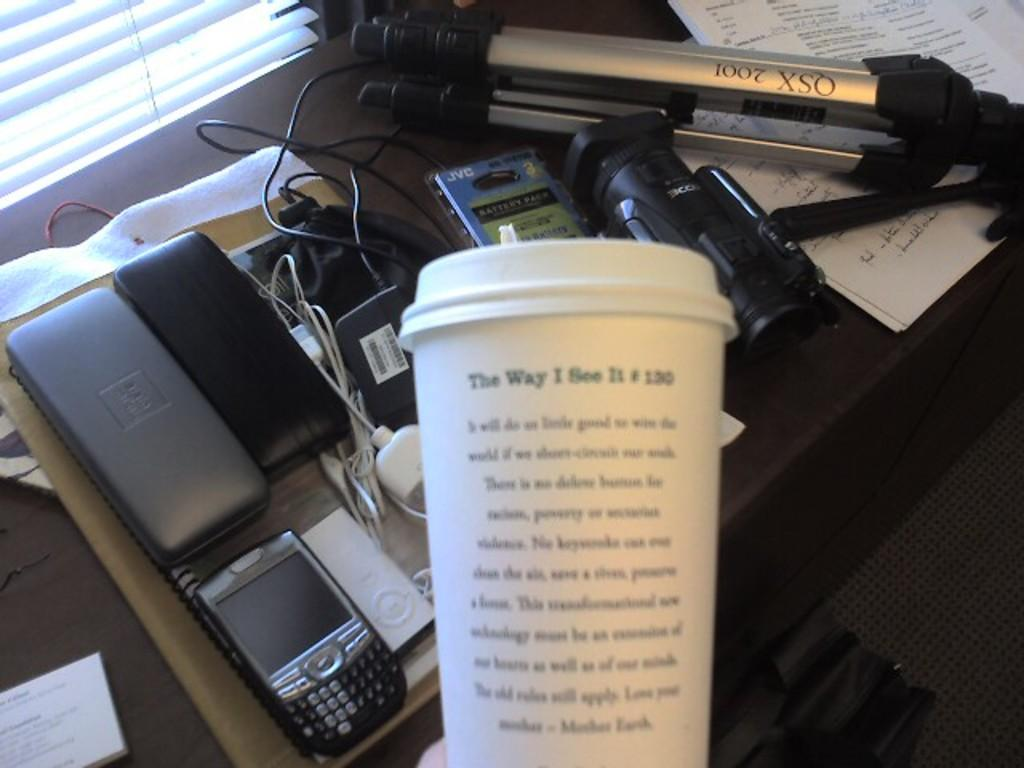<image>
Create a compact narrative representing the image presented. a coffee cup reads The Way I see it held above cluttered desk 